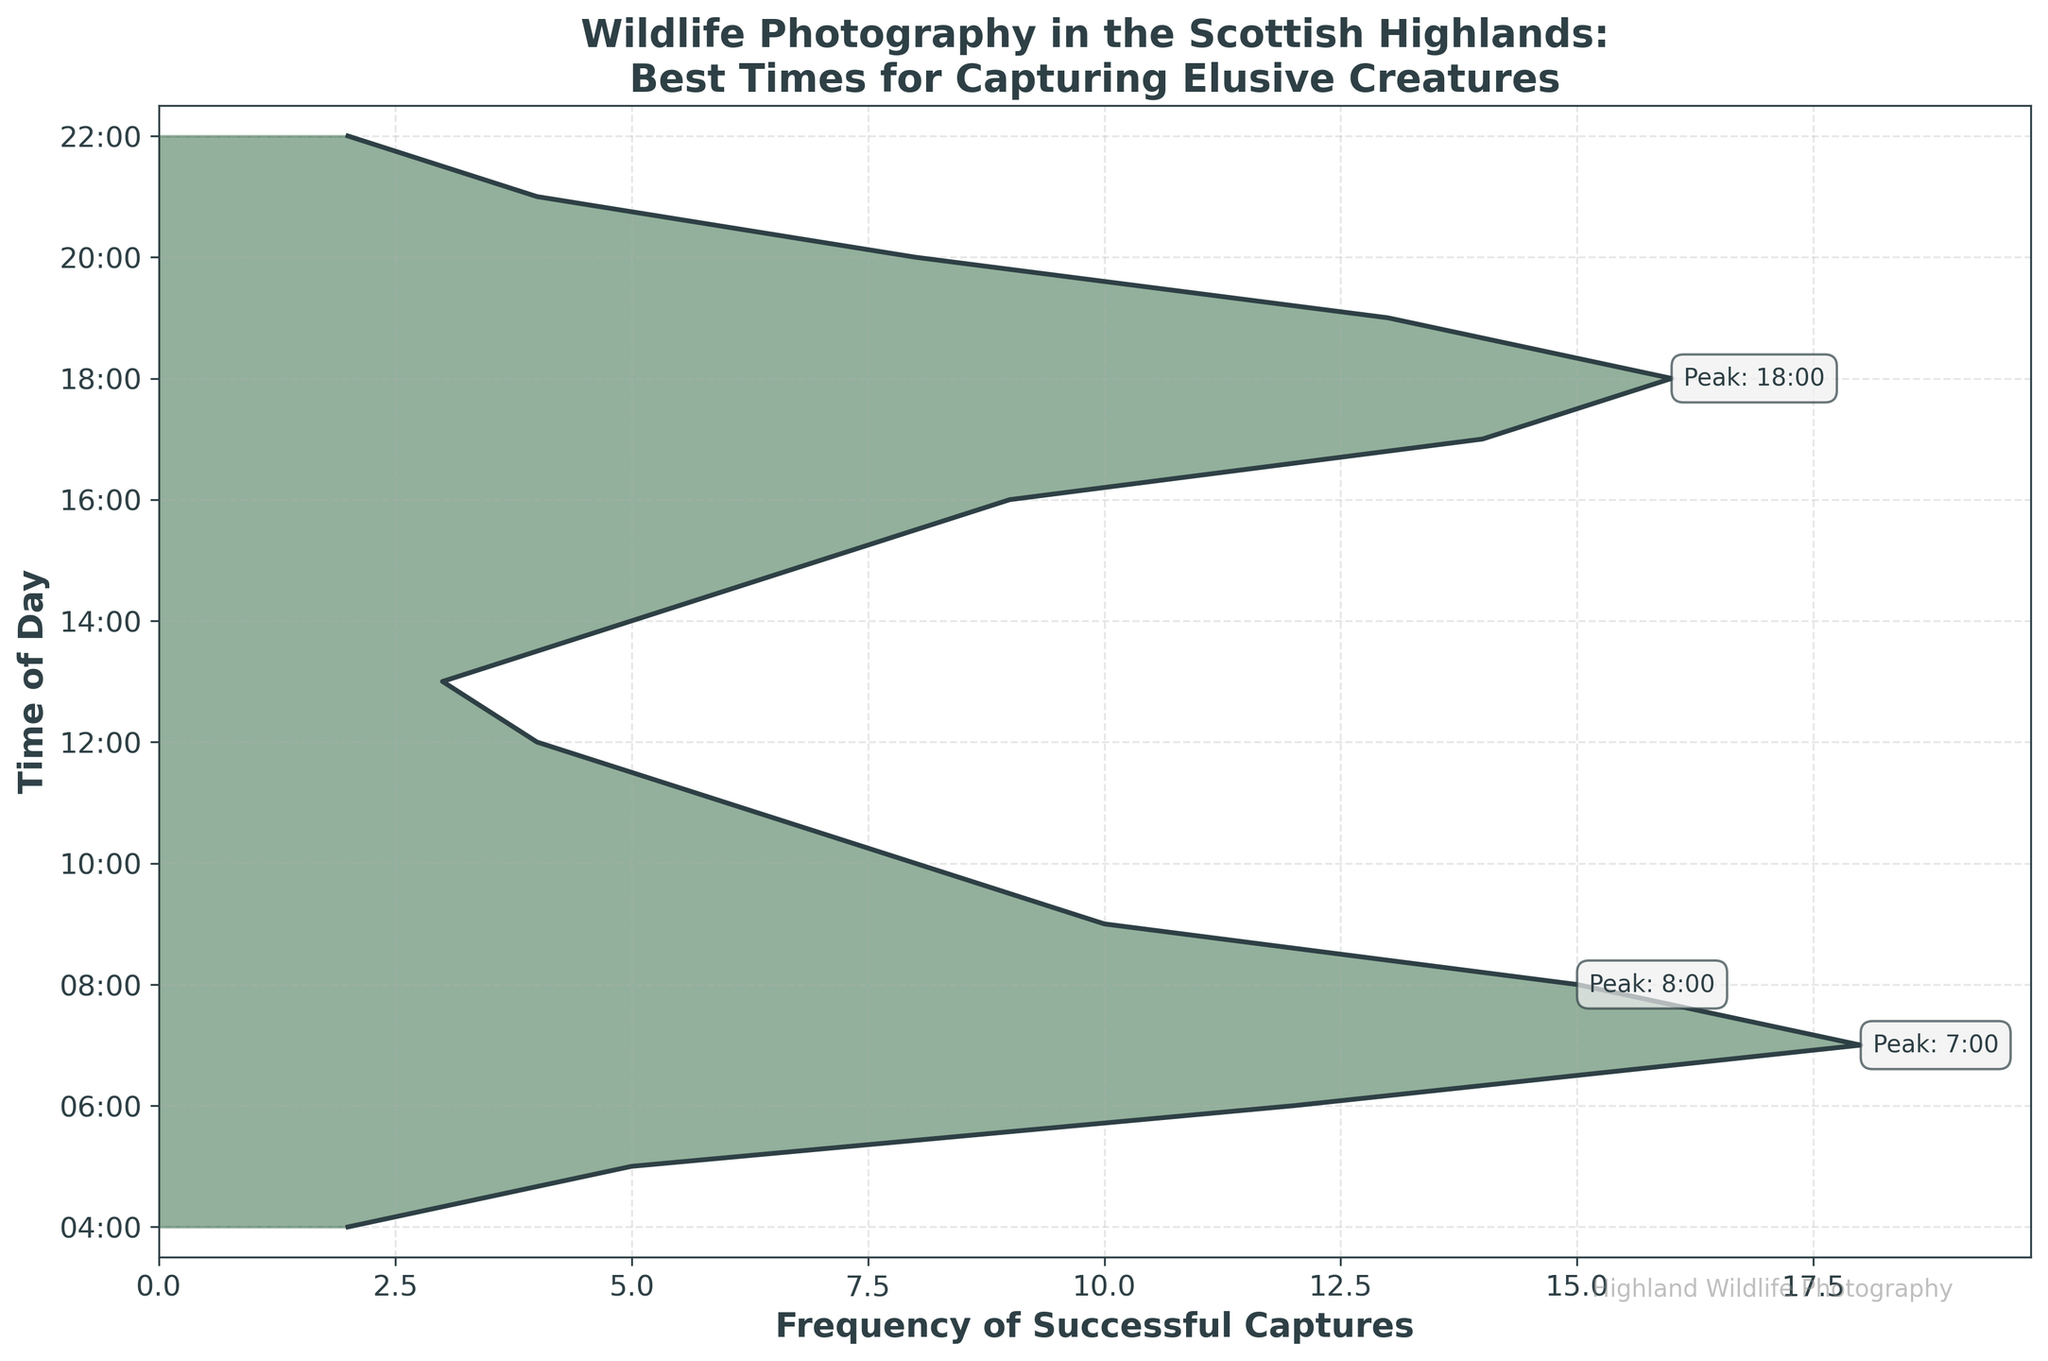Which time of day had the highest frequency of successful wildlife captures? Look for the peak of the density plot, which is the tallest point on the plot. The highest frequency is at 7:00.
Answer: 7:00 What is the title of the plot? Read the title at the top of the plot. The title is 'Wildlife Photography in the Scottish Highlands: Best Times for Capturing Elusive Creatures'.
Answer: Wildlife Photography in the Scottish Highlands: Best Times for Capturing Elusive Creatures How many successful captures were recorded at 18:00? Identify the frequency value for 18:00 from the vertical axis labels and corresponding data points.
Answer: 16 During which time intervals did successful captures occur more frequently, morning or evening? Compare the summed frequencies of the morning (4:00 to 11:00) and the evening (17:00 to 22:00). The morning interval has higher summed frequencies.
Answer: Morning What is the frequency difference between 6:00 and 20:00? Subtract the frequency at 20:00 (8) from the frequency at 6:00 (12). The difference is 4.
Answer: 4 At which time intervals does the frequency drop below 5? Check the frequencies at each time interval and identify those below 5, which are 4:00 and 22:00.
Answer: 4:00, 22:00 Which three time intervals are annotated as peaks? Look for the annotations marking "Peak" on the plot and note the times, which are 7:00, 17:00, and 18:00.
Answer: 7:00, 17:00, 18:00 How does the frequency at 15:00 compare to that at 14:00? Check the frequencies at both times; 15:00 has a frequency of 7 while 14:00 has a frequency of 5. Therefore, 15:00 is higher.
Answer: Higher What is the total frequency of successful captures from 7:00 to 9:00? Sum the frequencies of 7:00 (18), 8:00 (15), and 9:00 (10). Total is 43.
Answer: 43 Where in the timeline does the frequency start to consistently drop off in the afternoon? Observing the plot shows a consistent drop-off starting from 20:00.
Answer: 20:00 